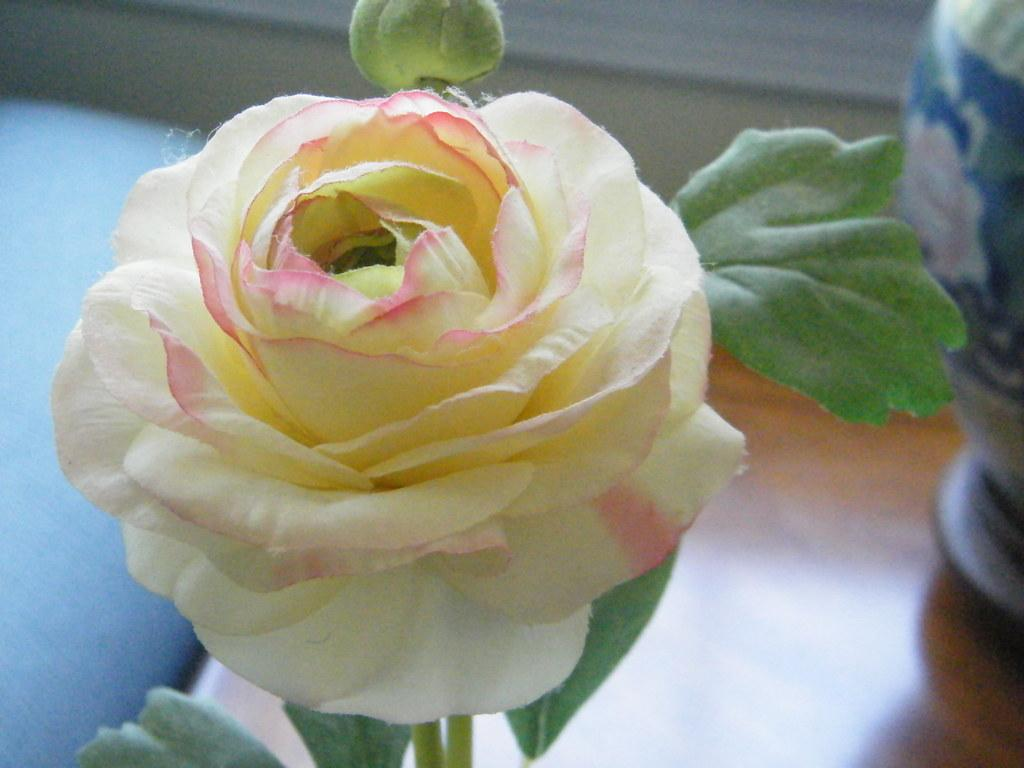What type of plant can be seen in the image? There is a flower and a plant bud in the image. Where are the flower and plant bud located? They are in the image, but their exact location is not specified. What can be seen in the background of the image? There is a vase and a wooden table in the background of the image. What color is the feather that is sparking in the image? There is no feather or spark present in the image. 